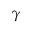Convert formula to latex. <formula><loc_0><loc_0><loc_500><loc_500>\gamma</formula> 